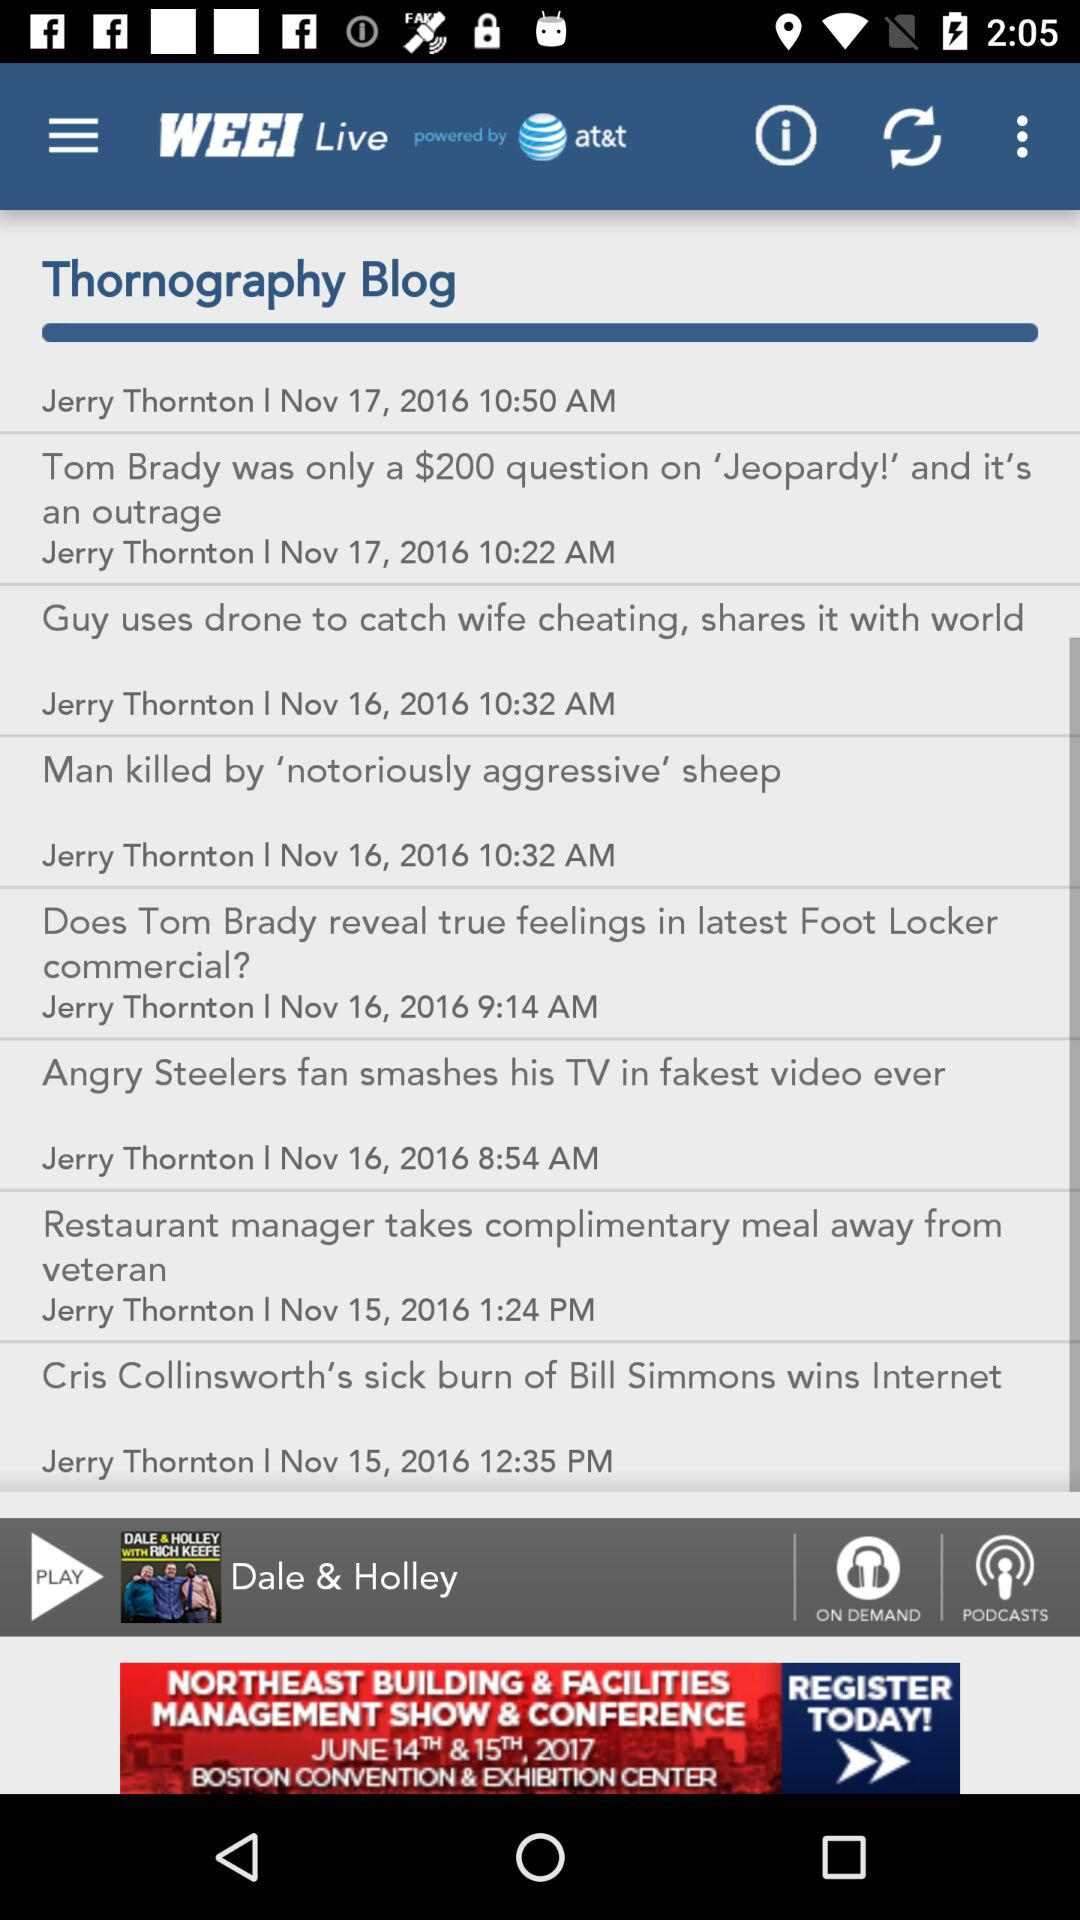What is the name of the application? The application name is "WEEI". 